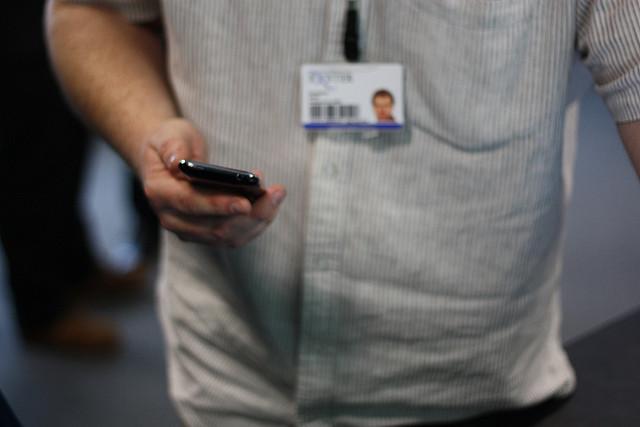What device is this person holding?
Quick response, please. Phone. Is this person wearing a name badge?
Short answer required. Yes. What is the gender of this person?
Keep it brief. Male. 